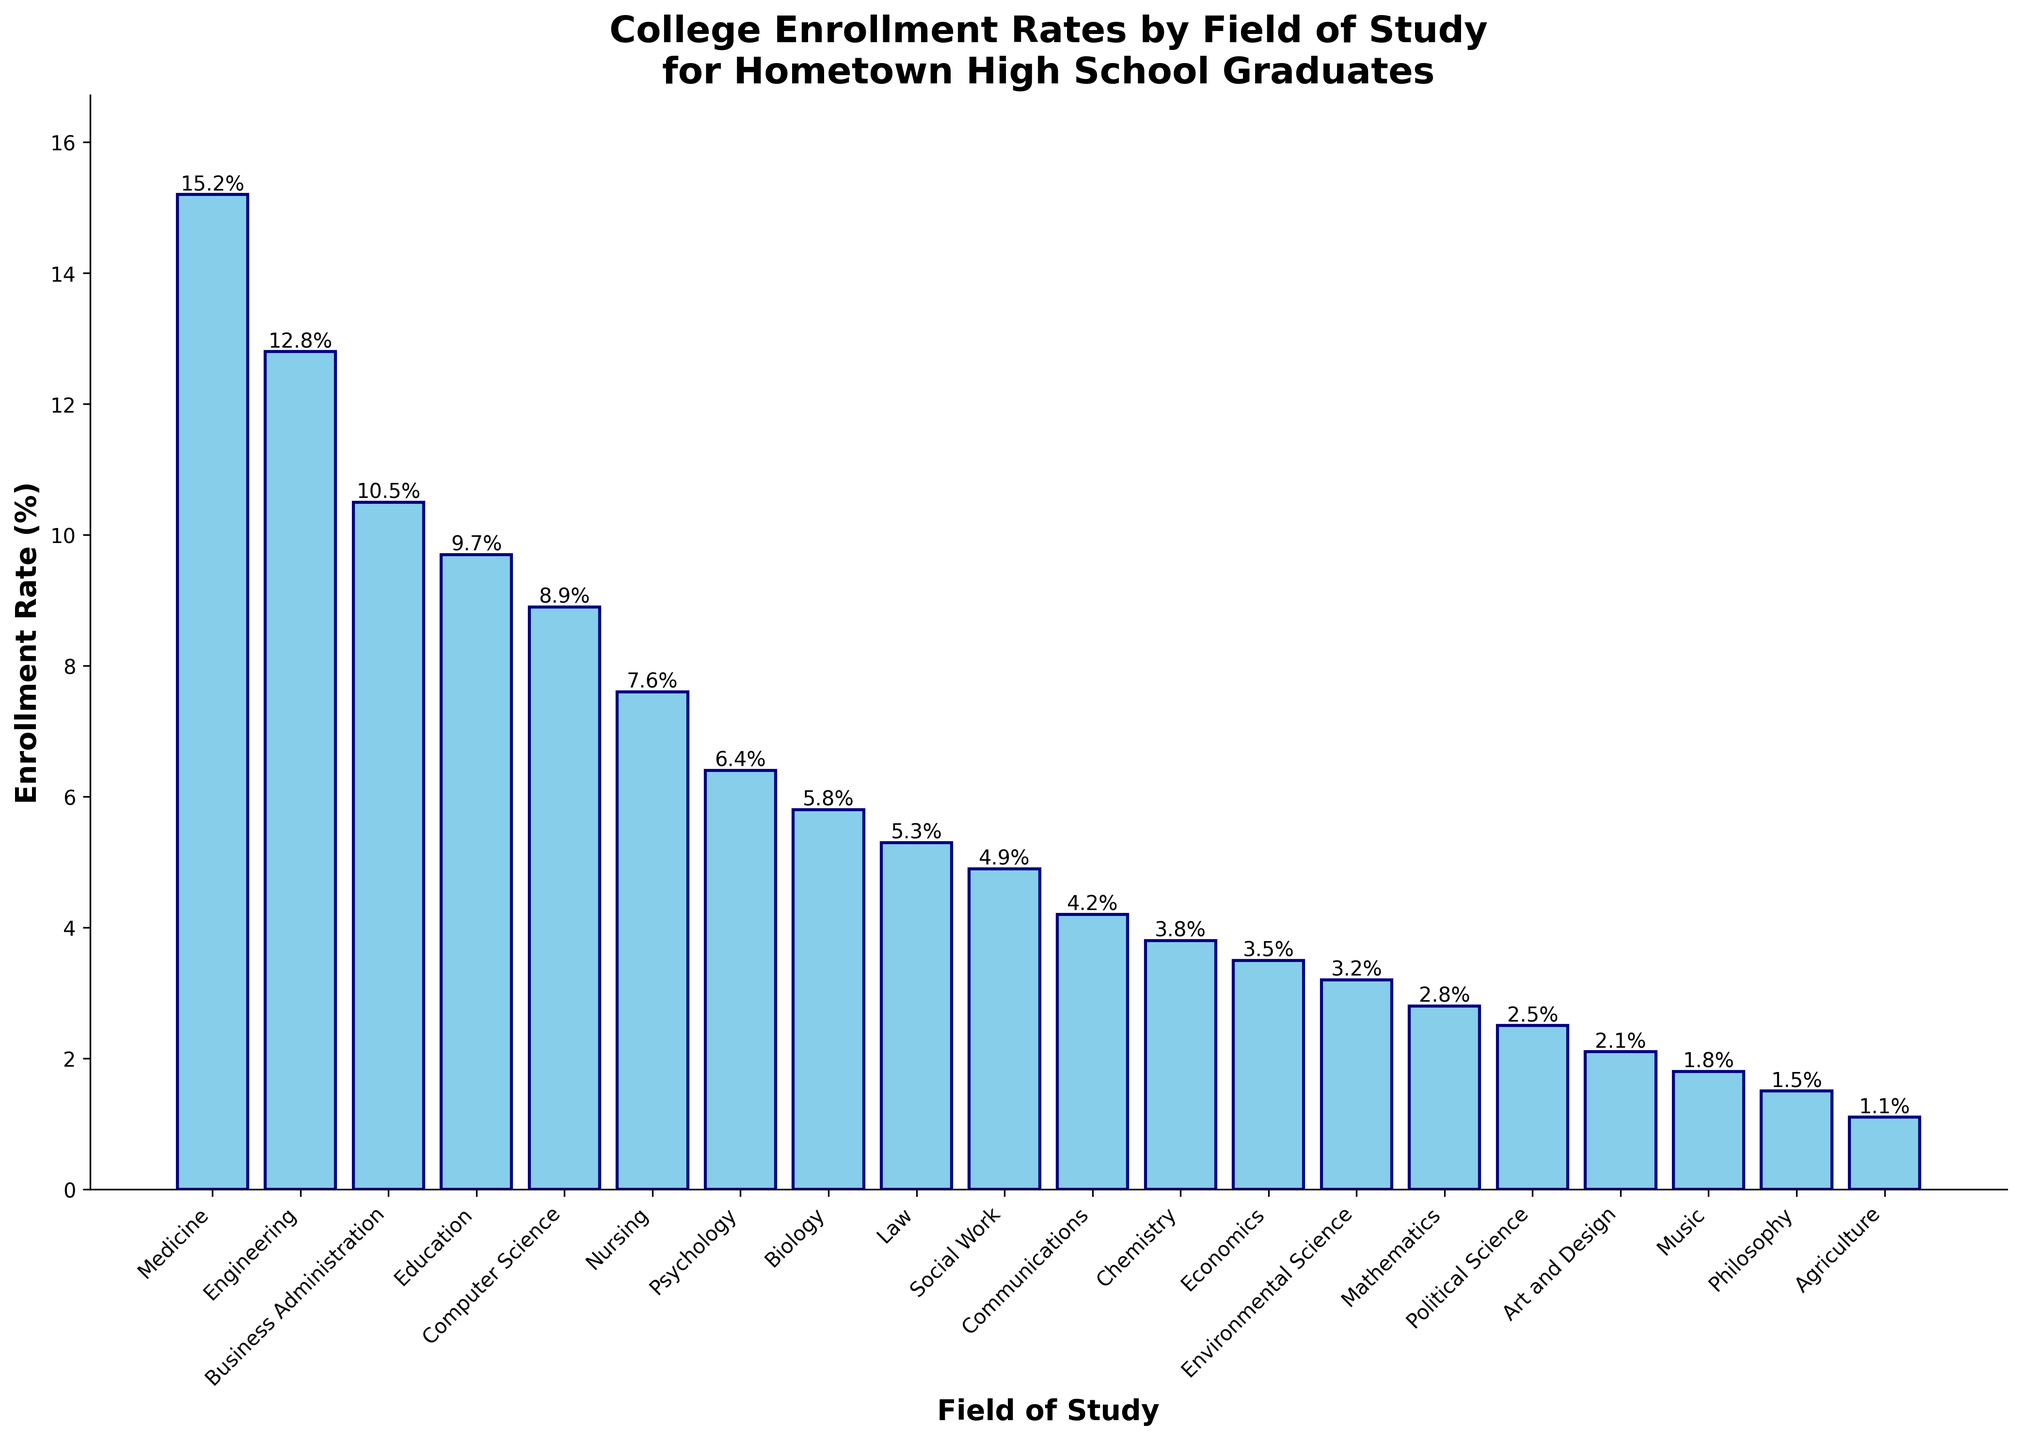What's the enrollment rate for Medicine compared to that for Business Administration? Identify the bars that correspond to "Medicine" and "Business Administration." The height of the "Medicine" bar is 15.2%, and the height of the "Business Administration" bar is 10.5%.
Answer: Medicine: 15.2%, Business Administration: 10.5% What is the combined enrollment rate for Psychology, Biology, and Nursing? Identify the bars for "Psychology," "Biology," and "Nursing" and note their heights: 6.4%, 5.8%, and 7.6%. Add these values: 6.4 + 5.8 + 7.6 = 19.8%.
Answer: 19.8% How many fields of study have an enrollment rate below 5%? Identify the bars with heights below 5%: Law, Social Work, Communications, Chemistry, Economics, Environmental Science, Mathematics, Political Science, Art and Design, Music, Philosophy, and Agriculture, which amounts to 12.
Answer: 12 Which field has the second highest enrollment rate, and what is it? Identify the bar with the highest value (Medicine at 15.2%) and then find the next highest bar (Engineering at 12.8%).
Answer: Engineering: 12.8% Is the enrollment rate for Computer Science greater than that for Education? Identify the bars for "Computer Science" and "Education." "Computer Science" has a rate of 8.9%, while "Education" has a rate of 9.7%. Since 8.9% is less than 9.7%, the rate for Computer Science is not greater.
Answer: No What is the average enrollment rate for the fields of Music, Economics, and Political Science? Identify the bars for "Music," "Economics," and "Political Science" and note their heights: 1.8%, 3.5%, and 2.5%. Calculate the average: (1.8 + 3.5 + 2.5) / 3 = 2.6%.
Answer: 2.6% Among the fields of Mathematics, Economics, and Environmental Science, which one has the highest enrollment rate? Identify the bars for "Mathematics," "Economics," and "Environmental Science." Their heights are 2.8%, 3.5%, and 3.2%, respectively. The highest among them is "Economics" at 3.5%.
Answer: Economics: 3.5% Is the enrollment rate for Engineering more than double that of Mathematics? The height of "Engineering" is 12.8%, and the height of "Mathematics" is 2.8%. Double the rate of Mathematics is 2.8 * 2 = 5.6%. Since 12.8% is greater than 5.6%, the rate for Engineering is more than double.
Answer: Yes 